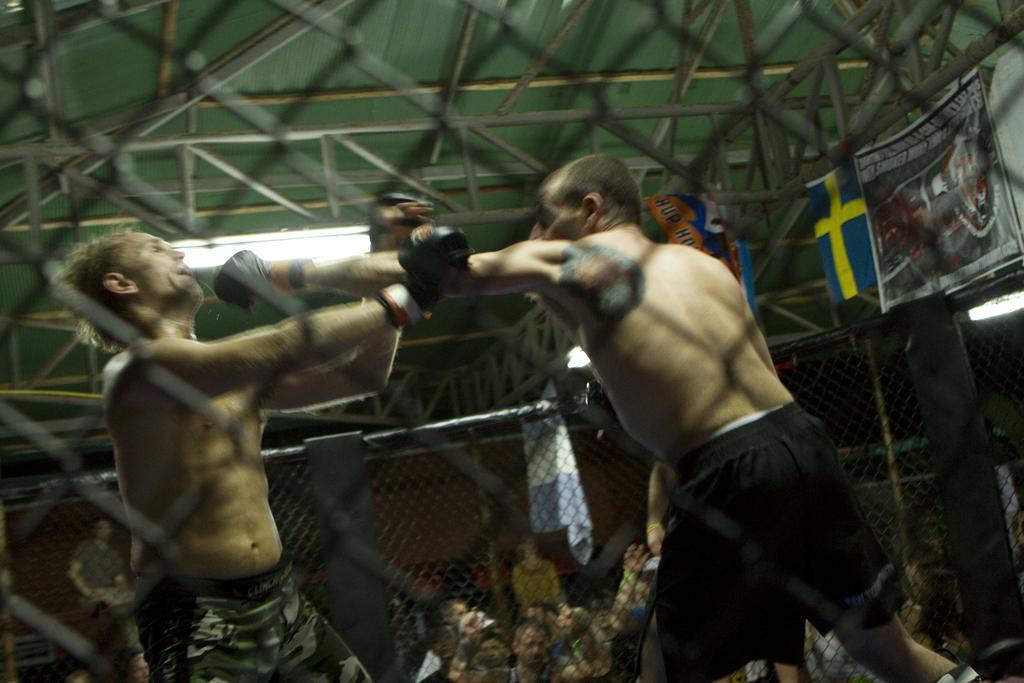Please provide a concise description of this image. This is an inside view. Here I can see two men are wearing shorts, gloves to the hands and fighting with each other. Around these men I can see the net. On the right side a banner is attached to this net. In the background there are many people looking at these people. On the top there is a window. 